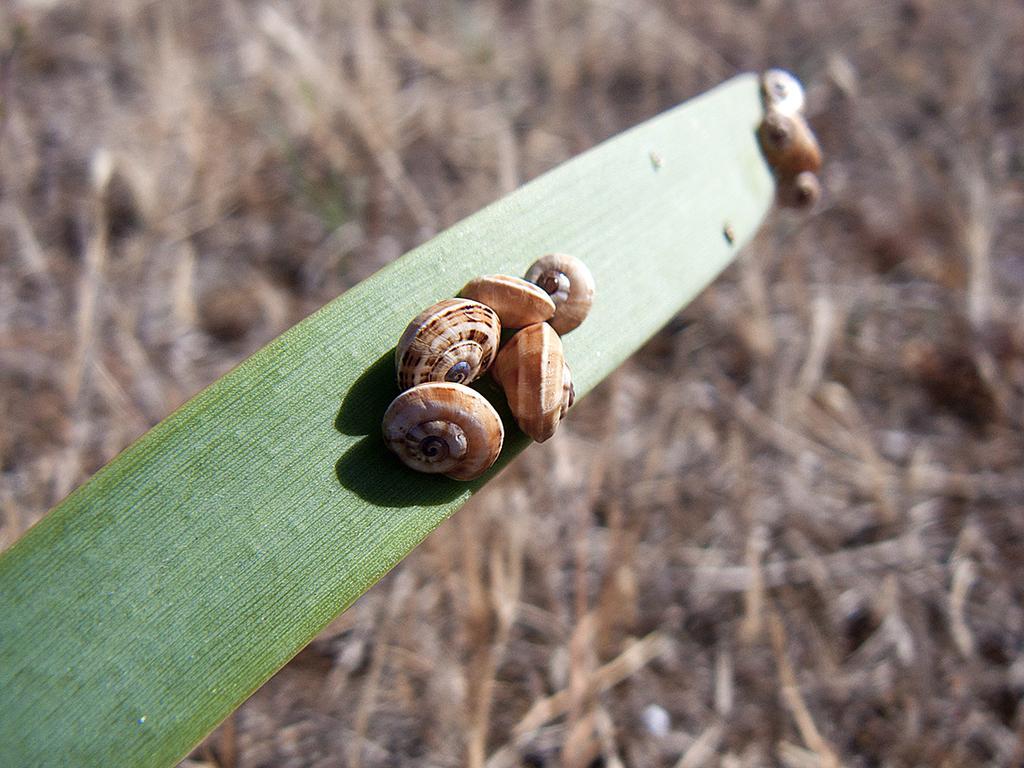Describe this image in one or two sentences. In this image I can see few pond snails on a leaf. The background is blurred. 